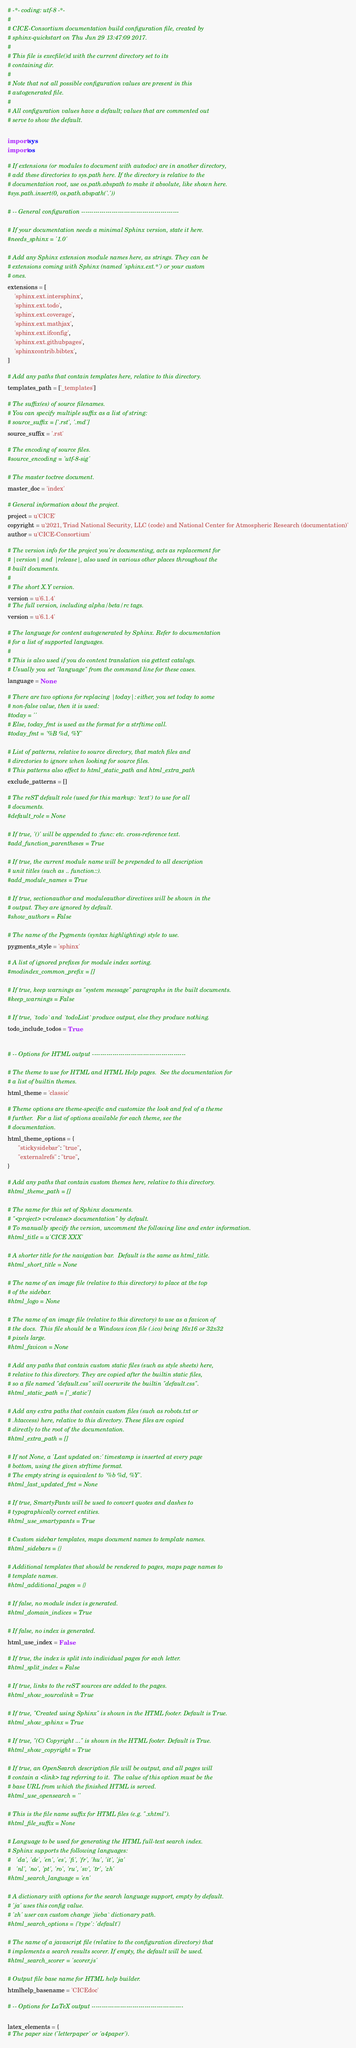<code> <loc_0><loc_0><loc_500><loc_500><_Python_># -*- coding: utf-8 -*-
#
# CICE-Consortium documentation build configuration file, created by
# sphinx-quickstart on Thu Jun 29 13:47:09 2017.
#
# This file is execfile()d with the current directory set to its
# containing dir.
#
# Note that not all possible configuration values are present in this
# autogenerated file.
#
# All configuration values have a default; values that are commented out
# serve to show the default.

import sys
import os

# If extensions (or modules to document with autodoc) are in another directory,
# add these directories to sys.path here. If the directory is relative to the
# documentation root, use os.path.abspath to make it absolute, like shown here.
#sys.path.insert(0, os.path.abspath('.'))

# -- General configuration ------------------------------------------------

# If your documentation needs a minimal Sphinx version, state it here.
#needs_sphinx = '1.0'

# Add any Sphinx extension module names here, as strings. They can be
# extensions coming with Sphinx (named 'sphinx.ext.*') or your custom
# ones.
extensions = [
    'sphinx.ext.intersphinx',
    'sphinx.ext.todo',
    'sphinx.ext.coverage',
    'sphinx.ext.mathjax',
    'sphinx.ext.ifconfig',
    'sphinx.ext.githubpages',
    'sphinxcontrib.bibtex',
]

# Add any paths that contain templates here, relative to this directory.
templates_path = ['_templates']

# The suffix(es) of source filenames.
# You can specify multiple suffix as a list of string:
# source_suffix = ['.rst', '.md']
source_suffix = '.rst'

# The encoding of source files.
#source_encoding = 'utf-8-sig'

# The master toctree document.
master_doc = 'index'

# General information about the project.
project = u'CICE'
copyright = u'2021, Triad National Security, LLC (code) and National Center for Atmospheric Research (documentation)'
author = u'CICE-Consortium'

# The version info for the project you're documenting, acts as replacement for
# |version| and |release|, also used in various other places throughout the
# built documents.
#
# The short X.Y version.
version = u'6.1.4' 
# The full version, including alpha/beta/rc tags.
version = u'6.1.4' 

# The language for content autogenerated by Sphinx. Refer to documentation
# for a list of supported languages.
#
# This is also used if you do content translation via gettext catalogs.
# Usually you set "language" from the command line for these cases.
language = None

# There are two options for replacing |today|: either, you set today to some
# non-false value, then it is used:
#today = ''
# Else, today_fmt is used as the format for a strftime call.
#today_fmt = '%B %d, %Y'

# List of patterns, relative to source directory, that match files and
# directories to ignore when looking for source files.
# This patterns also effect to html_static_path and html_extra_path
exclude_patterns = []

# The reST default role (used for this markup: `text`) to use for all
# documents.
#default_role = None

# If true, '()' will be appended to :func: etc. cross-reference text.
#add_function_parentheses = True

# If true, the current module name will be prepended to all description
# unit titles (such as .. function::).
#add_module_names = True

# If true, sectionauthor and moduleauthor directives will be shown in the
# output. They are ignored by default.
#show_authors = False

# The name of the Pygments (syntax highlighting) style to use.
pygments_style = 'sphinx'

# A list of ignored prefixes for module index sorting.
#modindex_common_prefix = []

# If true, keep warnings as "system message" paragraphs in the built documents.
#keep_warnings = False

# If true, `todo` and `todoList` produce output, else they produce nothing.
todo_include_todos = True


# -- Options for HTML output ----------------------------------------------

# The theme to use for HTML and HTML Help pages.  See the documentation for
# a list of builtin themes.
html_theme = 'classic'

# Theme options are theme-specific and customize the look and feel of a theme
# further.  For a list of options available for each theme, see the
# documentation.
html_theme_options = {
      "stickysidebar": "true",
      "externalrefs" : "true",
}

# Add any paths that contain custom themes here, relative to this directory.
#html_theme_path = []

# The name for this set of Sphinx documents.
# "<project> v<release> documentation" by default.
# To manually specify the version, uncomment the following line and enter information.
#html_title = u'CICE XXX'

# A shorter title for the navigation bar.  Default is the same as html_title.
#html_short_title = None

# The name of an image file (relative to this directory) to place at the top
# of the sidebar.
#html_logo = None

# The name of an image file (relative to this directory) to use as a favicon of
# the docs.  This file should be a Windows icon file (.ico) being 16x16 or 32x32
# pixels large.
#html_favicon = None

# Add any paths that contain custom static files (such as style sheets) here,
# relative to this directory. They are copied after the builtin static files,
# so a file named "default.css" will overwrite the builtin "default.css".
#html_static_path = ['_static']

# Add any extra paths that contain custom files (such as robots.txt or
# .htaccess) here, relative to this directory. These files are copied
# directly to the root of the documentation.
#html_extra_path = []

# If not None, a 'Last updated on:' timestamp is inserted at every page
# bottom, using the given strftime format.
# The empty string is equivalent to '%b %d, %Y'.
#html_last_updated_fmt = None

# If true, SmartyPants will be used to convert quotes and dashes to
# typographically correct entities.
#html_use_smartypants = True

# Custom sidebar templates, maps document names to template names.
#html_sidebars = {}

# Additional templates that should be rendered to pages, maps page names to
# template names.
#html_additional_pages = {}

# If false, no module index is generated.
#html_domain_indices = True

# If false, no index is generated.
html_use_index = False

# If true, the index is split into individual pages for each letter.
#html_split_index = False

# If true, links to the reST sources are added to the pages.
#html_show_sourcelink = True

# If true, "Created using Sphinx" is shown in the HTML footer. Default is True.
#html_show_sphinx = True

# If true, "(C) Copyright ..." is shown in the HTML footer. Default is True.
#html_show_copyright = True

# If true, an OpenSearch description file will be output, and all pages will
# contain a <link> tag referring to it.  The value of this option must be the
# base URL from which the finished HTML is served.
#html_use_opensearch = ''

# This is the file name suffix for HTML files (e.g. ".xhtml").
#html_file_suffix = None

# Language to be used for generating the HTML full-text search index.
# Sphinx supports the following languages:
#   'da', 'de', 'en', 'es', 'fi', 'fr', 'hu', 'it', 'ja'
#   'nl', 'no', 'pt', 'ro', 'ru', 'sv', 'tr', 'zh'
#html_search_language = 'en'

# A dictionary with options for the search language support, empty by default.
# 'ja' uses this config value.
# 'zh' user can custom change `jieba` dictionary path.
#html_search_options = {'type': 'default'}

# The name of a javascript file (relative to the configuration directory) that
# implements a search results scorer. If empty, the default will be used.
#html_search_scorer = 'scorer.js'

# Output file base name for HTML help builder.
htmlhelp_basename = 'CICEdoc'

# -- Options for LaTeX output ---------------------------------------------

latex_elements = {
# The paper size ('letterpaper' or 'a4paper').</code> 